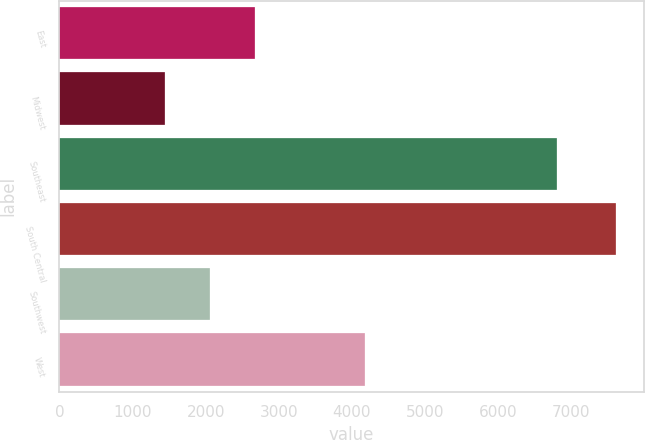Convert chart. <chart><loc_0><loc_0><loc_500><loc_500><bar_chart><fcel>East<fcel>Midwest<fcel>Southeast<fcel>South Central<fcel>Southwest<fcel>West<nl><fcel>2681<fcel>1449<fcel>6807<fcel>7609<fcel>2065<fcel>4180<nl></chart> 